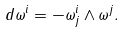Convert formula to latex. <formula><loc_0><loc_0><loc_500><loc_500>d \omega ^ { i } = - \omega ^ { i } _ { j } \wedge \omega ^ { j } .</formula> 